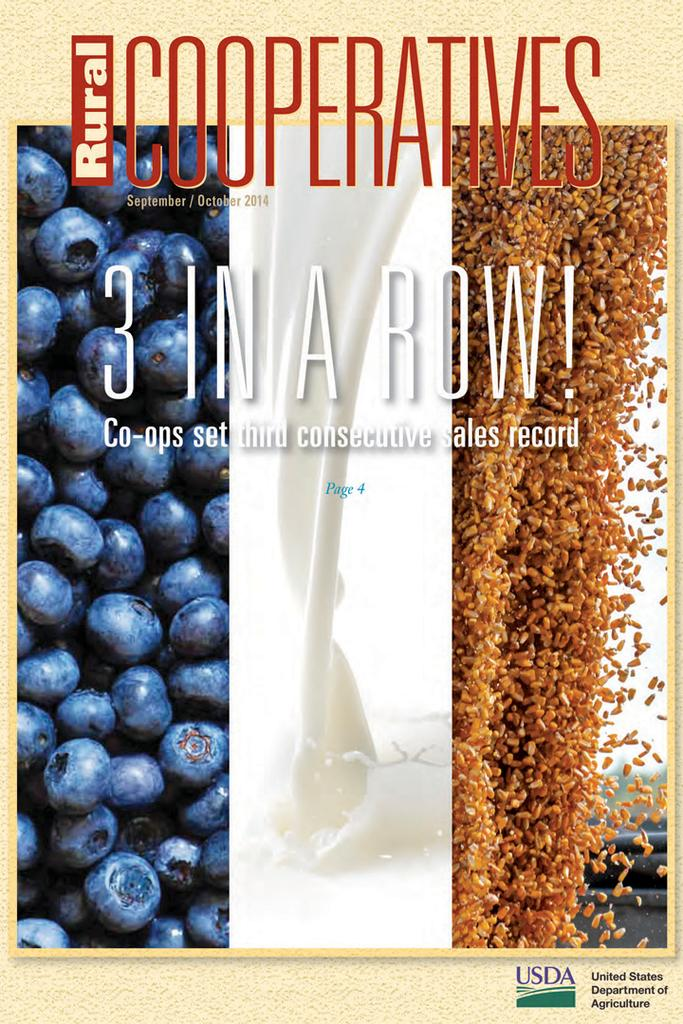<image>
Create a compact narrative representing the image presented. a close up of a poster for Rural Cooperatives 2014 